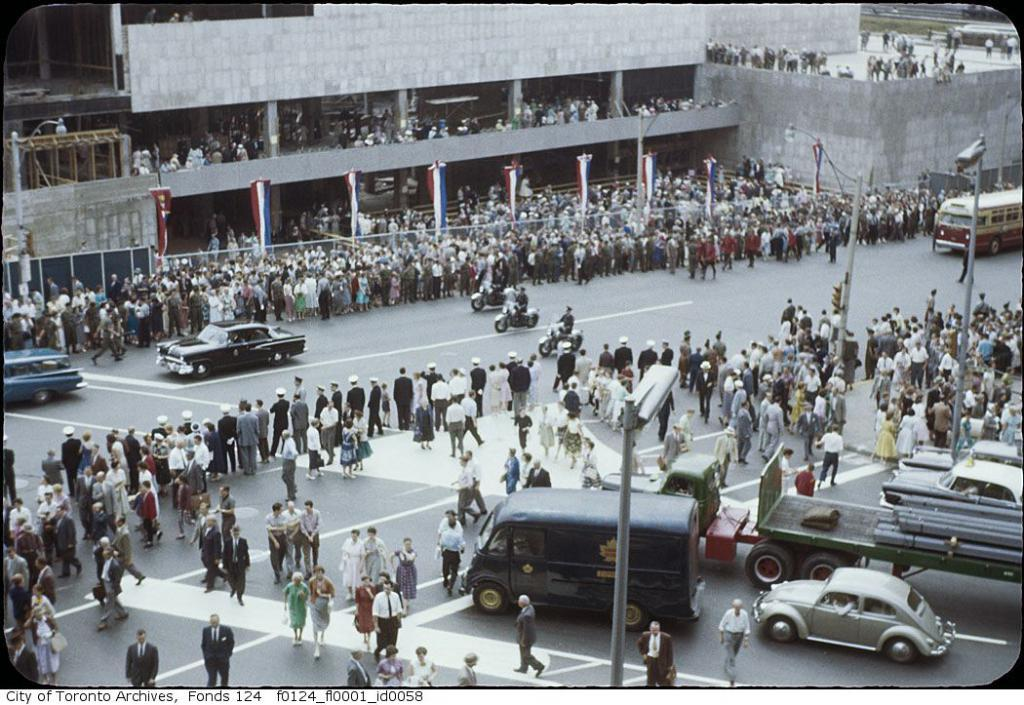Who or what can be seen in the image? There are people in the image. What else is visible in the image besides the people? There are vehicles on the road in the image. What can be seen in the distance in the image? There are buildings in the background of the image. What type of berry is being used as a prop in the image? There is no berry present in the image. What type of competition is taking place in the image? There is no competition present in the image. 